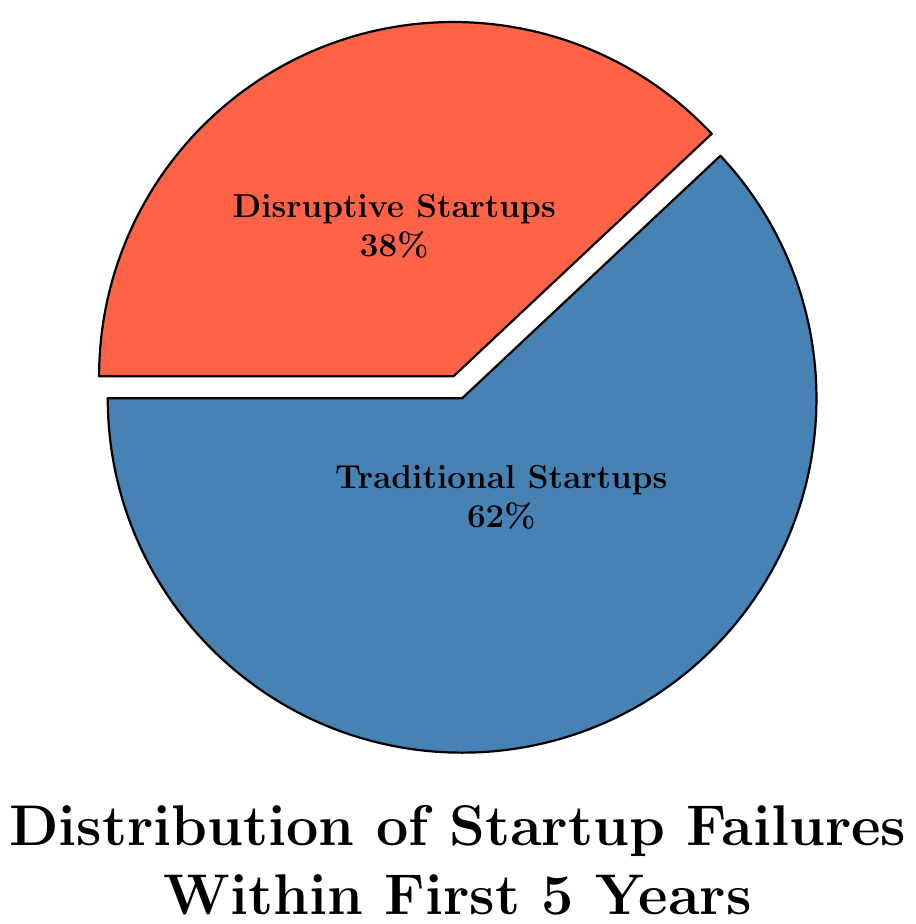What percentage of traditional startups fail within the first 5 years? The pie chart clearly shows the percentage of traditional startup failures labeled inside the corresponding segment.
Answer: 62% What is the difference in failure rates between traditional and disruptive startups within the first 5 years? To find the difference, subtract the smaller percentage from the larger one: 62% (Traditional Startups) - 38% (Disruptive Startups) = 24%.
Answer: 24% Which type of startups has a lower failure rate within the first 5 years? Compare the percentages shown in the pie chart. The disruptive startups have a lower percentage (38%) compared to traditional startups (62%).
Answer: Disruptive Startups What is the total percentage of startup failures depicted in the chart? The pie chart segments add up to show the total percentage of startup failures: 62% (Traditional Startups) + 38% (Disruptive Startups) = 100%.
Answer: 100% How do the colors help in distinguishing between traditional and disruptive startups? The pie chart uses different colors for each type of startup. Traditional startups are shown in blue, while disruptive startups are shown in red. This visual differentiation helps in quickly identifying the categories.
Answer: Different colors are used: blue for traditional startups and red for disruptive startups If you divide the percentage of disruptive startup failures by the percentage of traditional startup failures, what is the ratio? To find the ratio, divide the percentage of disruptive startup failures by the percentage of traditional startup failures: 38% / 62% = 0.6129.
Answer: 0.6129 What fraction of the startups that fail within the first 5 years are disruptive startups? The pie chart shows that 38% of the startups that fail are disruptive startups. This represents the fraction 38/100 or 19/50.
Answer: 19/50 By how much would the percentage of traditional startup failures need to decrease to equal the percentage of disruptive startup failures? The percentage of traditional startup failures is 62%, and the percentage of disruptive startup failures is 38%. To equalize the percentages, the traditional startup failures would need to decrease by 24%: 62% - 38% = 24%.
Answer: 24% If the failure rate of disruptive startups increases by 10%, what would their new failure rate be? Start with the current failure rate of disruptive startups, which is 38%. Add 10% to this rate: 38% + 10% = 48%.
Answer: 48% What percentage of startups are successful within the first 5 years? To find the percentage of startups that are successful, subtract the total percentage of failures from 100%. Here, the total failure rate is 100%, so the success rate is 0%.
Answer: 0% 